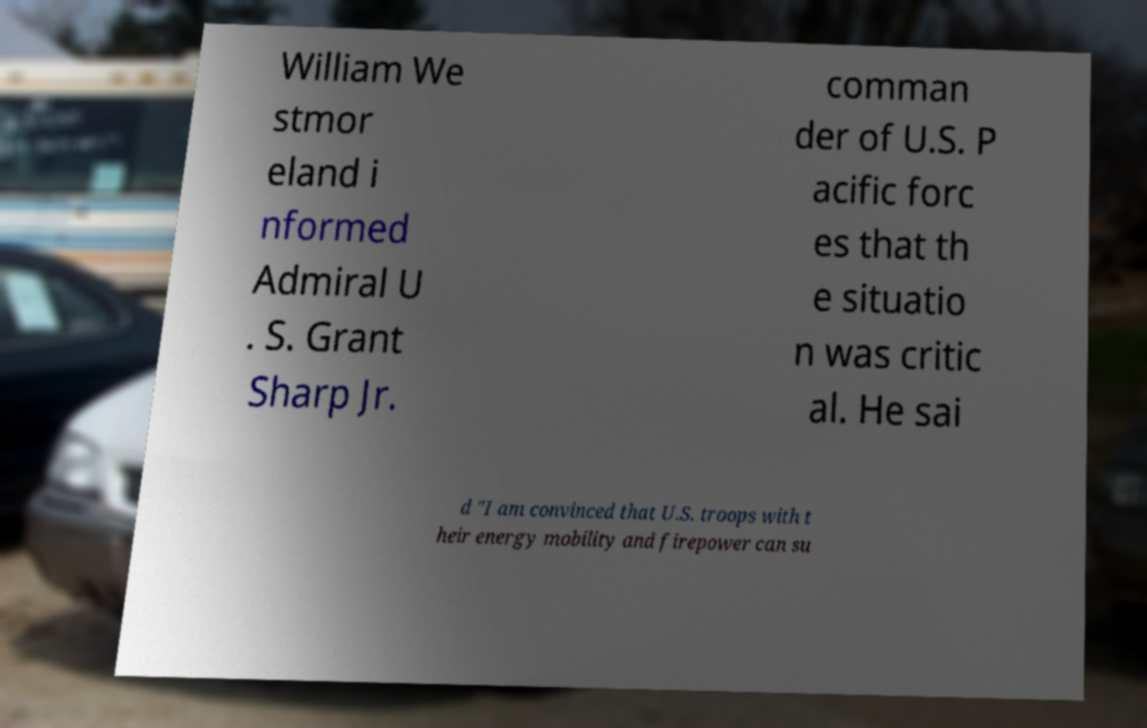Can you accurately transcribe the text from the provided image for me? William We stmor eland i nformed Admiral U . S. Grant Sharp Jr. comman der of U.S. P acific forc es that th e situatio n was critic al. He sai d "I am convinced that U.S. troops with t heir energy mobility and firepower can su 